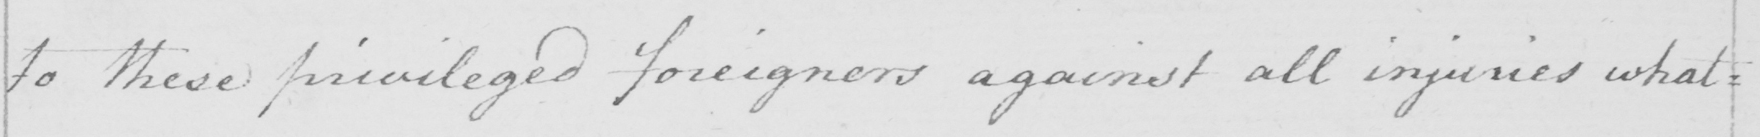What is written in this line of handwriting? to these privileged foreigners against all injuries what= 